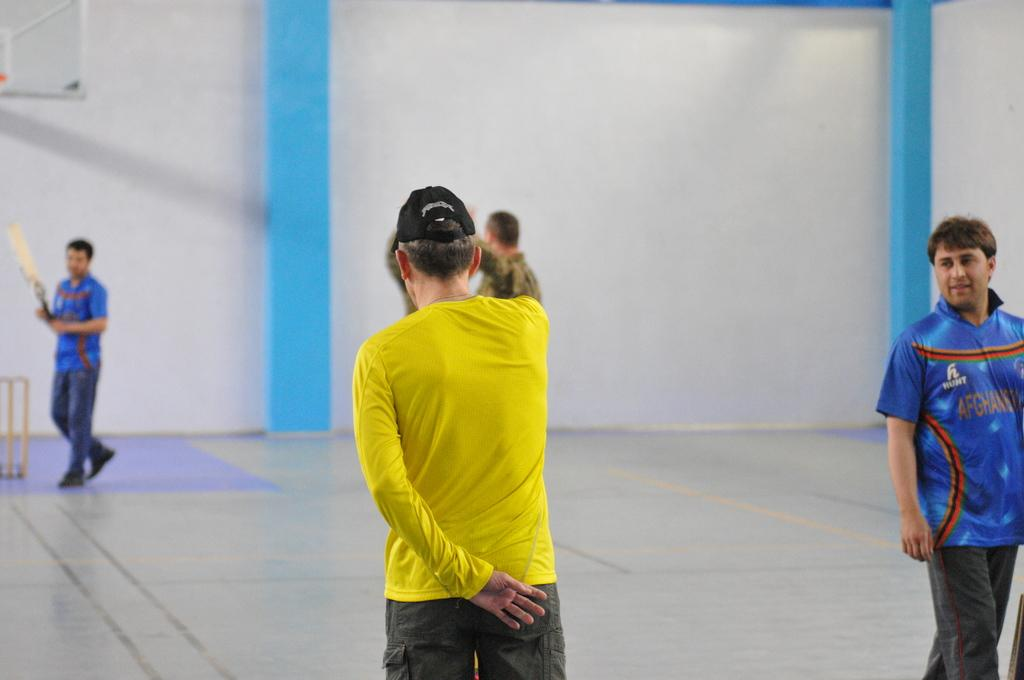<image>
Render a clear and concise summary of the photo. people in a sports gym wearing jerseys reading HUNT 